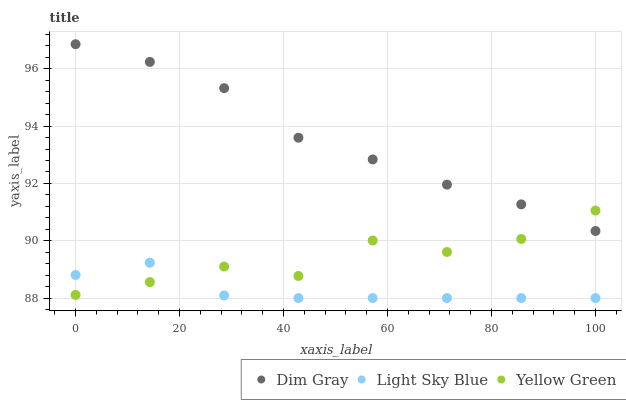Does Light Sky Blue have the minimum area under the curve?
Answer yes or no. Yes. Does Dim Gray have the maximum area under the curve?
Answer yes or no. Yes. Does Yellow Green have the minimum area under the curve?
Answer yes or no. No. Does Yellow Green have the maximum area under the curve?
Answer yes or no. No. Is Dim Gray the smoothest?
Answer yes or no. Yes. Is Yellow Green the roughest?
Answer yes or no. Yes. Is Light Sky Blue the smoothest?
Answer yes or no. No. Is Light Sky Blue the roughest?
Answer yes or no. No. Does Light Sky Blue have the lowest value?
Answer yes or no. Yes. Does Yellow Green have the lowest value?
Answer yes or no. No. Does Dim Gray have the highest value?
Answer yes or no. Yes. Does Yellow Green have the highest value?
Answer yes or no. No. Is Light Sky Blue less than Dim Gray?
Answer yes or no. Yes. Is Dim Gray greater than Light Sky Blue?
Answer yes or no. Yes. Does Yellow Green intersect Light Sky Blue?
Answer yes or no. Yes. Is Yellow Green less than Light Sky Blue?
Answer yes or no. No. Is Yellow Green greater than Light Sky Blue?
Answer yes or no. No. Does Light Sky Blue intersect Dim Gray?
Answer yes or no. No. 